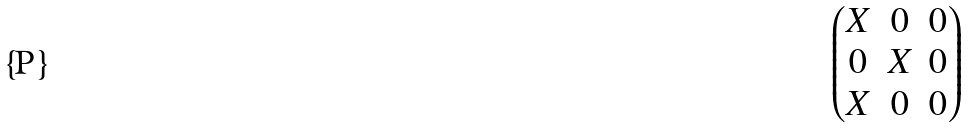Convert formula to latex. <formula><loc_0><loc_0><loc_500><loc_500>\begin{pmatrix} X & 0 & 0 \\ 0 & X & 0 \\ X & 0 & 0 \\ \end{pmatrix}</formula> 